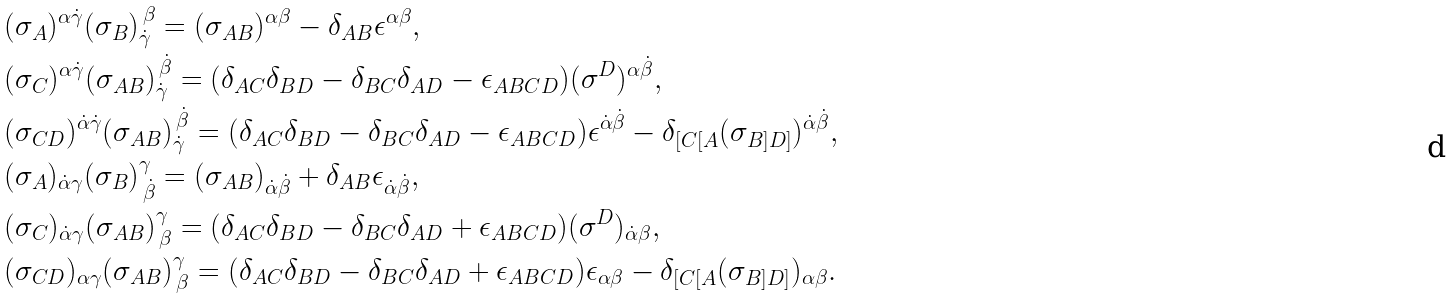Convert formula to latex. <formula><loc_0><loc_0><loc_500><loc_500>& ( \sigma _ { A } ) ^ { \alpha \dot { \gamma } } ( \sigma _ { B } ) _ { \dot { \gamma } } ^ { \, \beta } = ( \sigma _ { A B } ) ^ { \alpha \beta } - \delta _ { A B } \epsilon ^ { \alpha \beta } , \\ & ( \sigma _ { C } ) ^ { \alpha \dot { \gamma } } ( \sigma _ { A B } ) _ { \dot { \gamma } } ^ { \, \dot { \beta } } = ( \delta _ { A C } \delta _ { B D } - \delta _ { B C } \delta _ { A D } - \epsilon _ { A B C D } ) ( \sigma ^ { D } ) ^ { \alpha \dot { \beta } } , \\ & ( \sigma _ { C D } ) ^ { \dot { \alpha } \dot { \gamma } } ( \sigma _ { A B } ) _ { \dot { \gamma } } ^ { \, \dot { \beta } } = ( \delta _ { A C } \delta _ { B D } - \delta _ { B C } \delta _ { A D } - \epsilon _ { A B C D } ) \epsilon ^ { \dot { \alpha } \dot { \beta } } - \delta _ { [ C [ A } ( \sigma _ { B ] D ] } ) ^ { \dot { \alpha } \dot { \beta } } , \\ & ( \sigma _ { A } ) _ { \dot { \alpha } \gamma } ( \sigma _ { B } ) ^ { \gamma } _ { \, \dot { \beta } } = ( \sigma _ { A B } ) _ { \dot { \alpha } \dot { \beta } } + \delta _ { A B } \epsilon _ { \dot { \alpha } \dot { \beta } } , \\ & ( \sigma _ { C } ) _ { \dot { \alpha } \gamma } ( \sigma _ { A B } ) ^ { \gamma } _ { \, \beta } = ( \delta _ { A C } \delta _ { B D } - \delta _ { B C } \delta _ { A D } + \epsilon _ { A B C D } ) ( \sigma ^ { D } ) _ { \dot { \alpha } \beta } , \\ & ( \sigma _ { C D } ) _ { \alpha \gamma } ( \sigma _ { A B } ) ^ { \gamma } _ { \, \beta } = ( \delta _ { A C } \delta _ { B D } - \delta _ { B C } \delta _ { A D } + \epsilon _ { A B C D } ) \epsilon _ { \alpha \beta } - \delta _ { [ C [ A } ( \sigma _ { B ] D ] } ) _ { \alpha \beta } .</formula> 